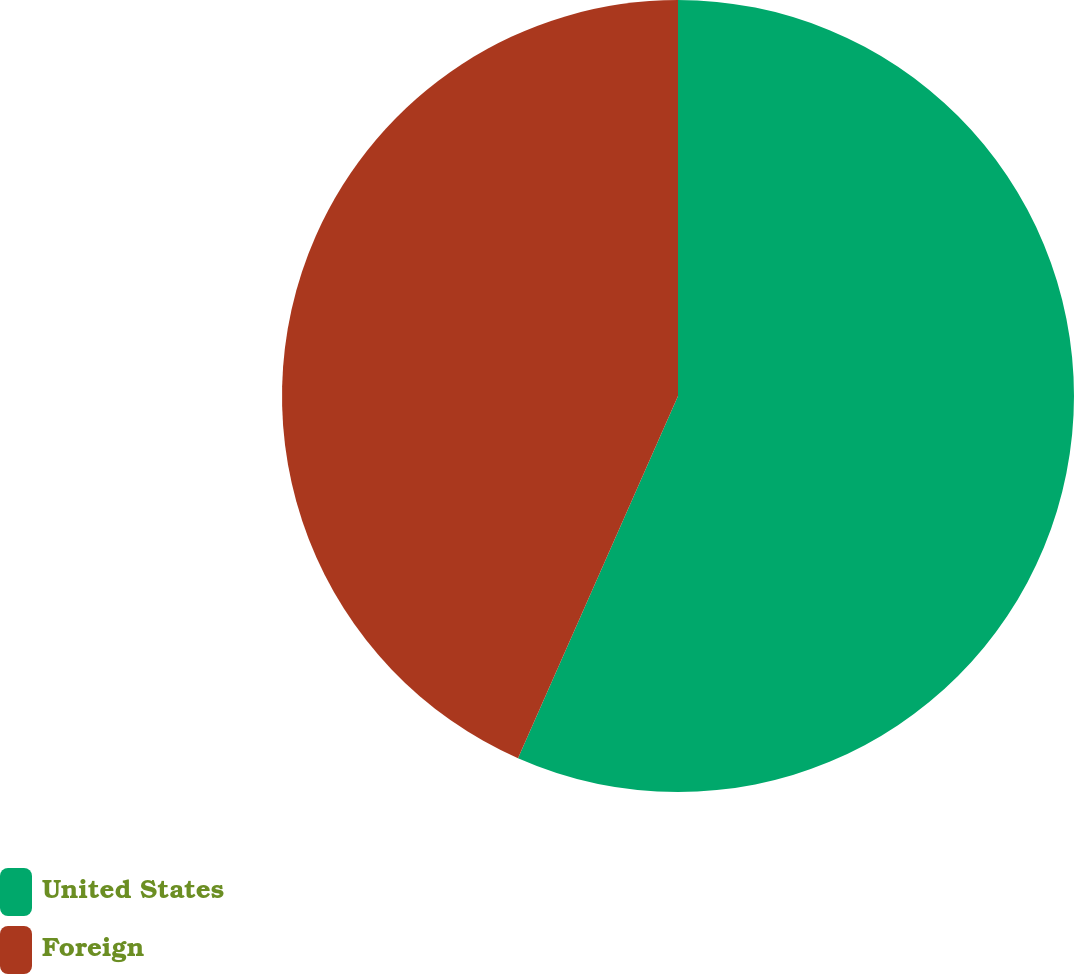Convert chart. <chart><loc_0><loc_0><loc_500><loc_500><pie_chart><fcel>United States<fcel>Foreign<nl><fcel>56.62%<fcel>43.38%<nl></chart> 